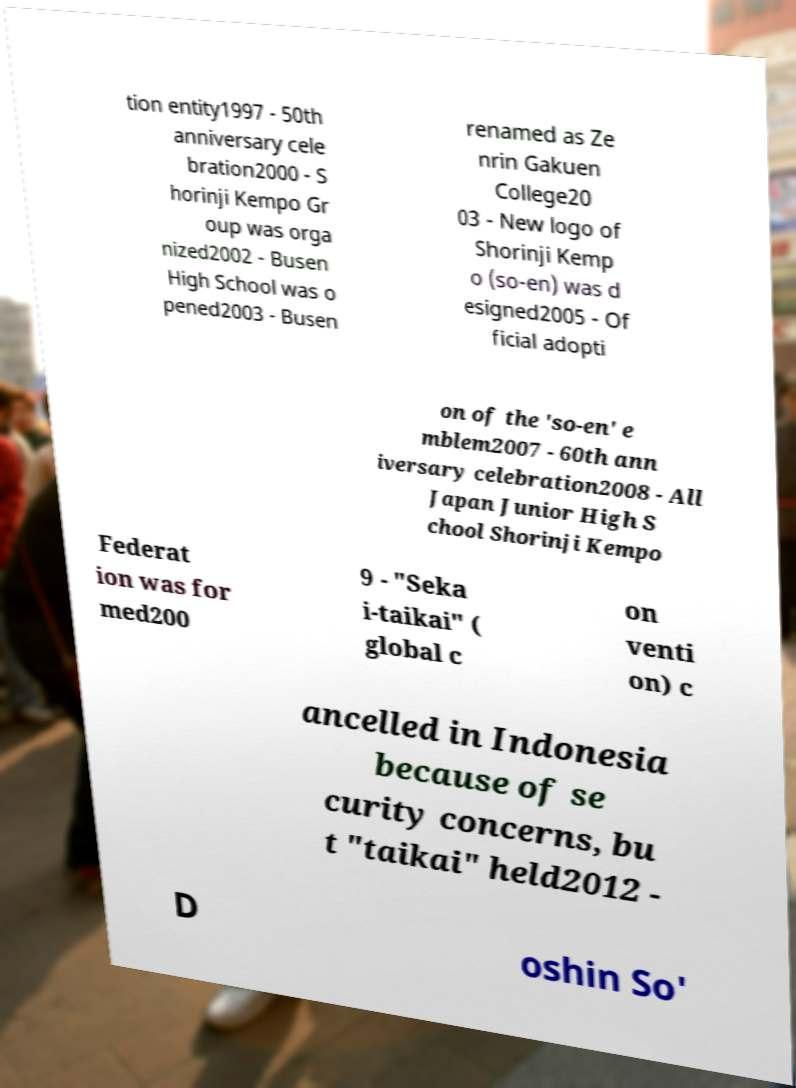Please identify and transcribe the text found in this image. tion entity1997 - 50th anniversary cele bration2000 - S horinji Kempo Gr oup was orga nized2002 - Busen High School was o pened2003 - Busen renamed as Ze nrin Gakuen College20 03 - New logo of Shorinji Kemp o (so-en) was d esigned2005 - Of ficial adopti on of the 'so-en' e mblem2007 - 60th ann iversary celebration2008 - All Japan Junior High S chool Shorinji Kempo Federat ion was for med200 9 - "Seka i-taikai" ( global c on venti on) c ancelled in Indonesia because of se curity concerns, bu t "taikai" held2012 - D oshin So' 